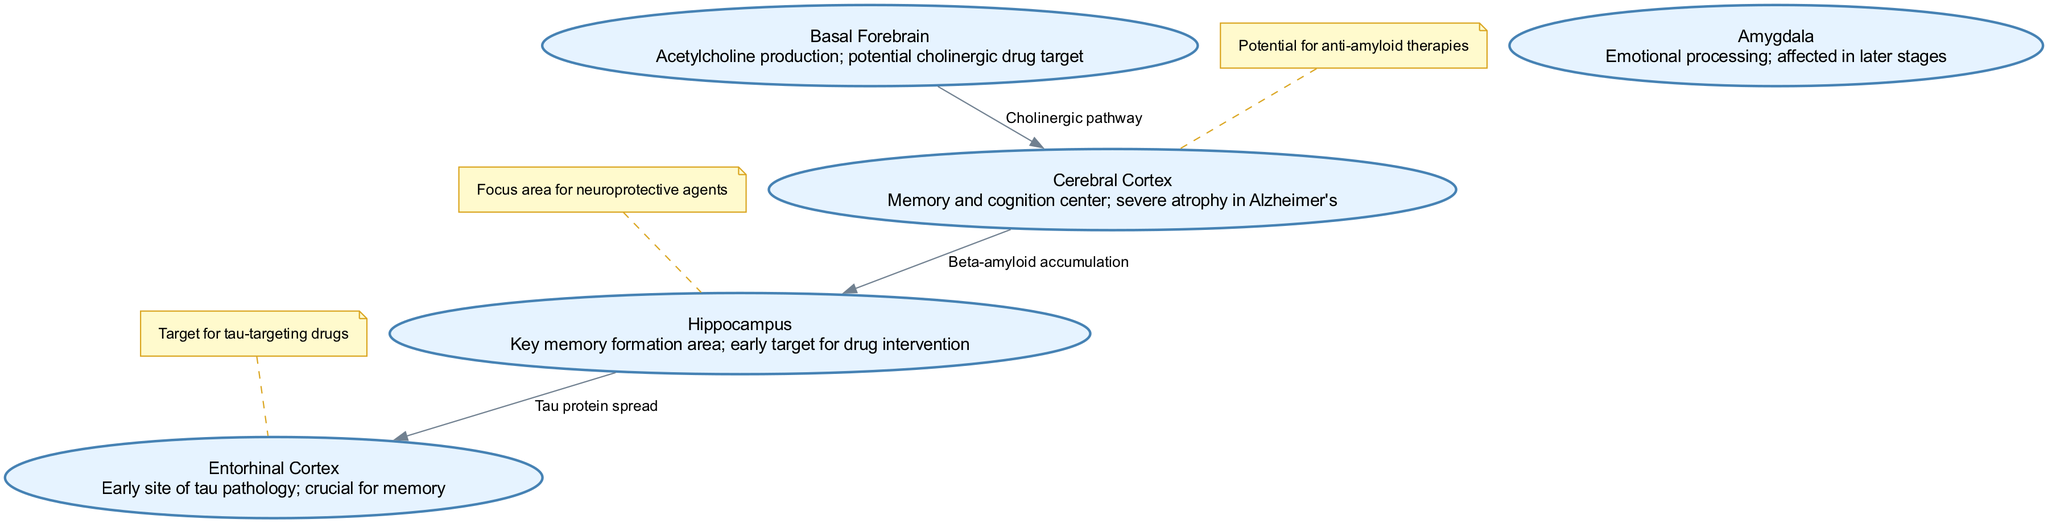What is the primary function of the hippocampus? The diagram describes the hippocampus as the key memory formation area, indicating its crucial role in memory processes, especially in the context of Alzheimer's disease.
Answer: Key memory formation area How many nodes are present in the diagram? The diagram contains five nodes representing different brain regions affected by Alzheimer's disease: cerebral cortex, hippocampus, amygdala, basal forebrain, and entorhinal cortex.
Answer: Five What is the relationship between the cerebral cortex and the hippocampus? The diagram depicts a directed edge from the cerebral cortex to the hippocampus labeled "Beta-amyloid accumulation," indicating that there is a relationship between these two regions regarding the effects of beta-amyloid in Alzheimer's disease.
Answer: Beta-amyloid accumulation Which region is an early target for drug intervention? According to the diagram, the hippocampus is indicated as an early target for drug intervention, focusing on potential treatments for Alzheimer's in its early stages.
Answer: Hippocampus What annotation is linked to the entorhinal cortex? The entorhinal cortex in the diagram is annotated with "Target for tau-targeting drugs," indicating a potential area for drug development aimed at tau pathology in Alzheimer's disease.
Answer: Target for tau-targeting drugs Which pathway does the basal forebrain affect? The diagram illustrates that the basal forebrain influences the cholinergic pathway leading to the cerebral cortex, suggesting its role in acetylcholine production and memory regulation.
Answer: Cholinergic pathway What is the significance of tau protein spread according to the diagram? The diagram connects the hippocampus to the entorhinal cortex with labeled edges indicating "Tau protein spread," highlighting the progression of tau pathology in these regions of the brain affected by Alzheimer's disease.
Answer: Tau protein spread What potential therapies are mentioned for the cerebral cortex? The annotation linked to the cerebral cortex states there is "Potential for anti-amyloid therapies," suggesting a possible avenue for treatment targeting amyloid accumulation in that region.
Answer: Potential for anti-amyloid therapies 